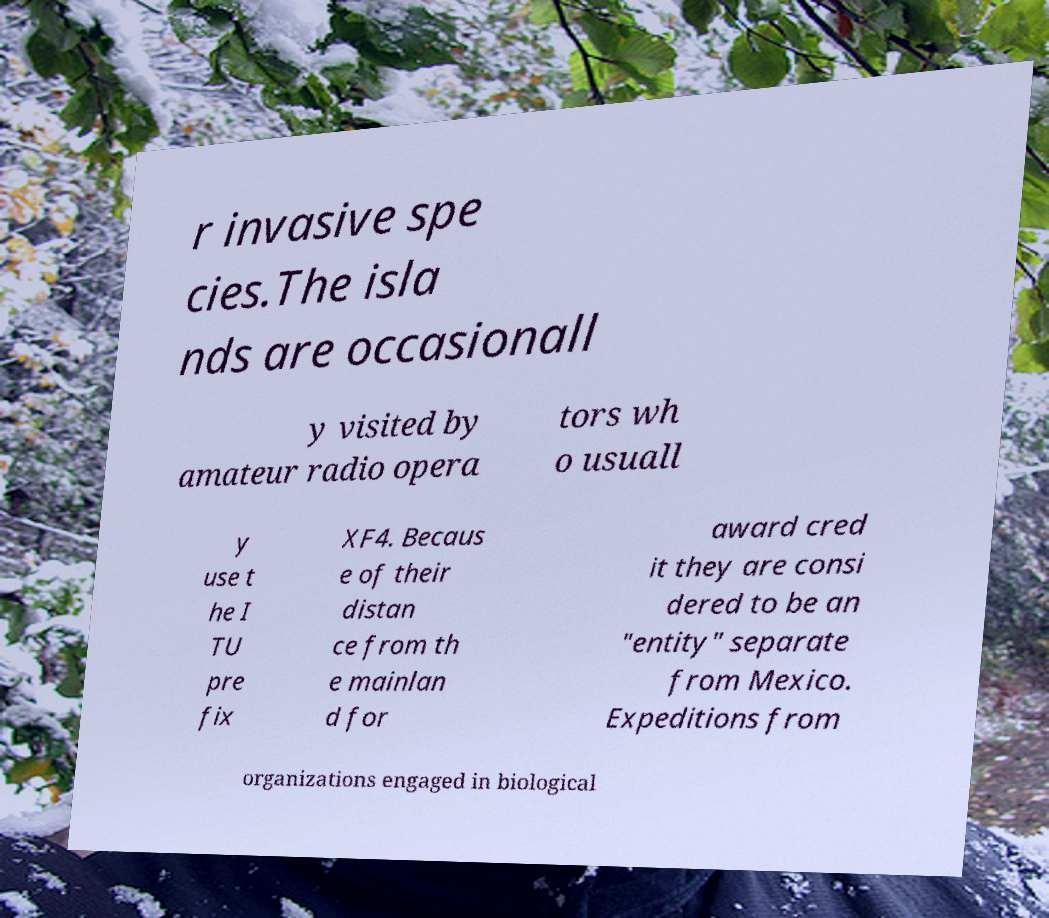I need the written content from this picture converted into text. Can you do that? r invasive spe cies.The isla nds are occasionall y visited by amateur radio opera tors wh o usuall y use t he I TU pre fix XF4. Becaus e of their distan ce from th e mainlan d for award cred it they are consi dered to be an "entity" separate from Mexico. Expeditions from organizations engaged in biological 